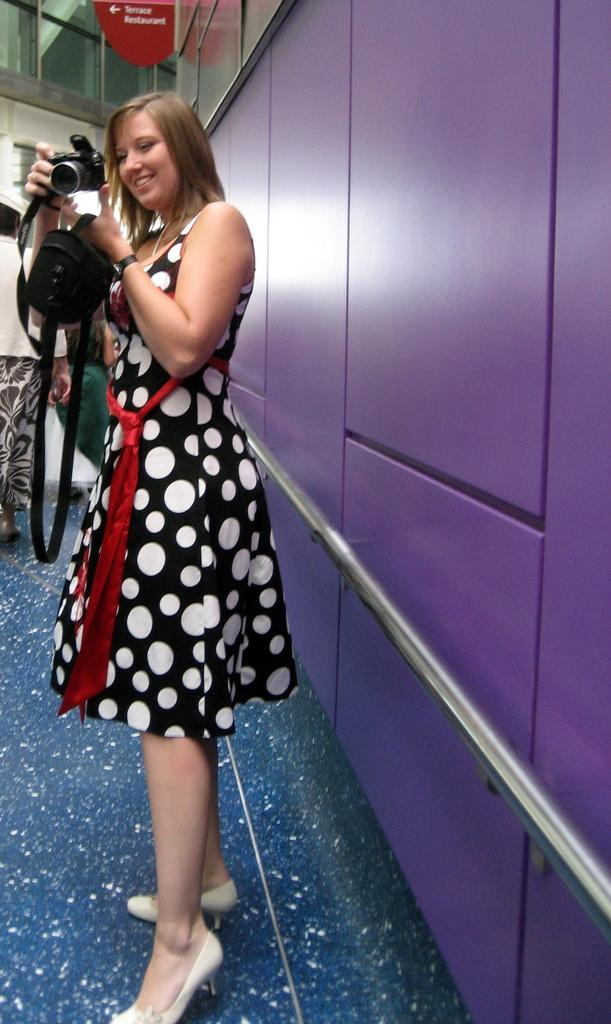Who is the main subject in the image? There is a woman in the image. What is the woman doing in the image? The woman is standing in the image. What is the woman holding in her hand? The woman is holding a camera in her hand. What else is the woman holding in the image? The woman is also holding a bag. What can be seen in the background of the image? There is a wall in the background of the image. What type of fish can be seen swimming near the edge of the image? There is no fish present in the image, and there is no edge visible in the image. 